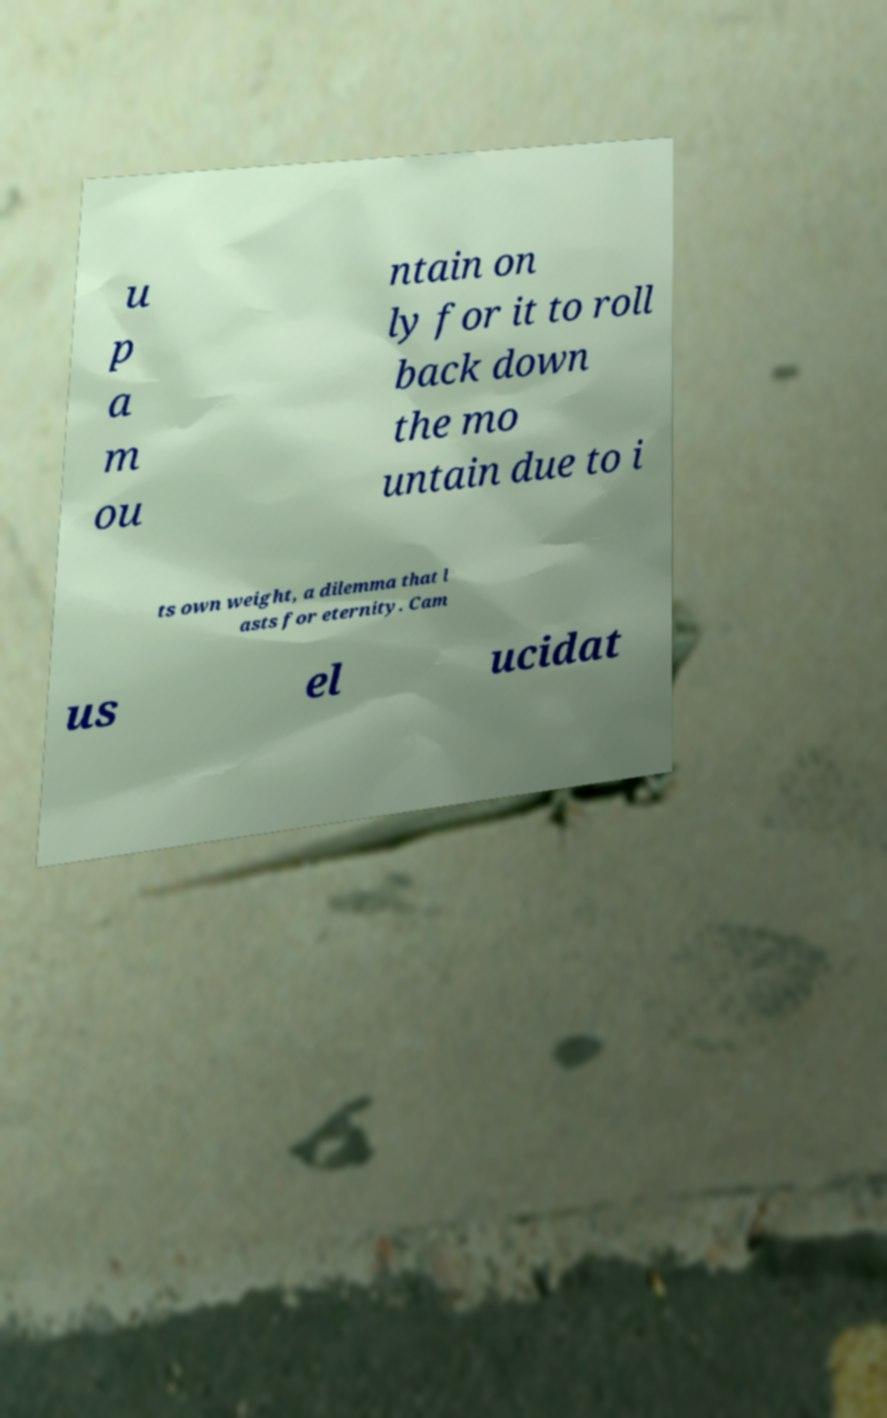For documentation purposes, I need the text within this image transcribed. Could you provide that? u p a m ou ntain on ly for it to roll back down the mo untain due to i ts own weight, a dilemma that l asts for eternity. Cam us el ucidat 